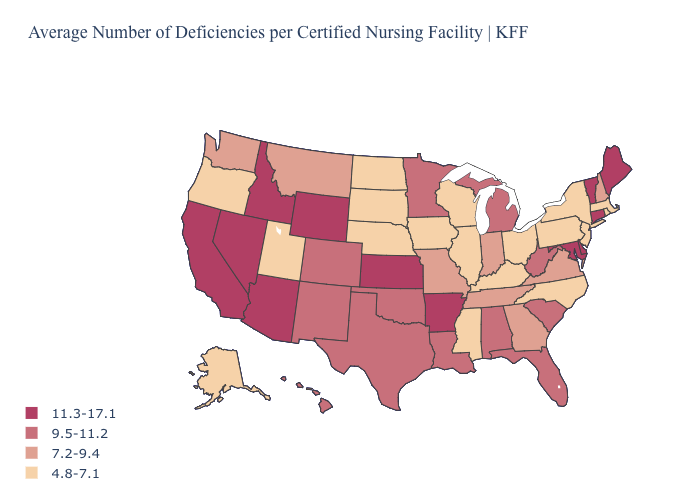Is the legend a continuous bar?
Keep it brief. No. What is the highest value in the USA?
Answer briefly. 11.3-17.1. What is the value of Alabama?
Short answer required. 9.5-11.2. Which states have the lowest value in the USA?
Write a very short answer. Alaska, Illinois, Iowa, Kentucky, Massachusetts, Mississippi, Nebraska, New Jersey, New York, North Carolina, North Dakota, Ohio, Oregon, Pennsylvania, Rhode Island, South Dakota, Utah, Wisconsin. Does the first symbol in the legend represent the smallest category?
Concise answer only. No. What is the value of Wyoming?
Be succinct. 11.3-17.1. What is the value of Minnesota?
Write a very short answer. 9.5-11.2. Which states have the lowest value in the USA?
Concise answer only. Alaska, Illinois, Iowa, Kentucky, Massachusetts, Mississippi, Nebraska, New Jersey, New York, North Carolina, North Dakota, Ohio, Oregon, Pennsylvania, Rhode Island, South Dakota, Utah, Wisconsin. Name the states that have a value in the range 11.3-17.1?
Give a very brief answer. Arizona, Arkansas, California, Connecticut, Delaware, Idaho, Kansas, Maine, Maryland, Nevada, Vermont, Wyoming. How many symbols are there in the legend?
Quick response, please. 4. What is the value of Pennsylvania?
Write a very short answer. 4.8-7.1. Does Vermont have the highest value in the USA?
Write a very short answer. Yes. Does Idaho have the highest value in the USA?
Short answer required. Yes. Does the map have missing data?
Short answer required. No. Name the states that have a value in the range 9.5-11.2?
Concise answer only. Alabama, Colorado, Florida, Hawaii, Louisiana, Michigan, Minnesota, New Mexico, Oklahoma, South Carolina, Texas, West Virginia. 